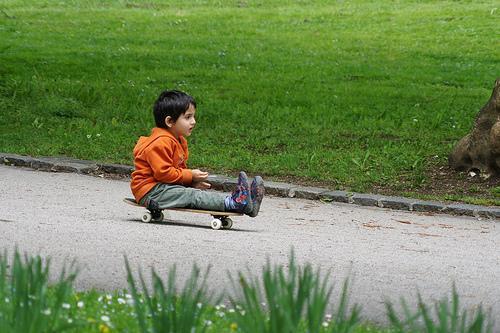How many children are there?
Give a very brief answer. 1. 